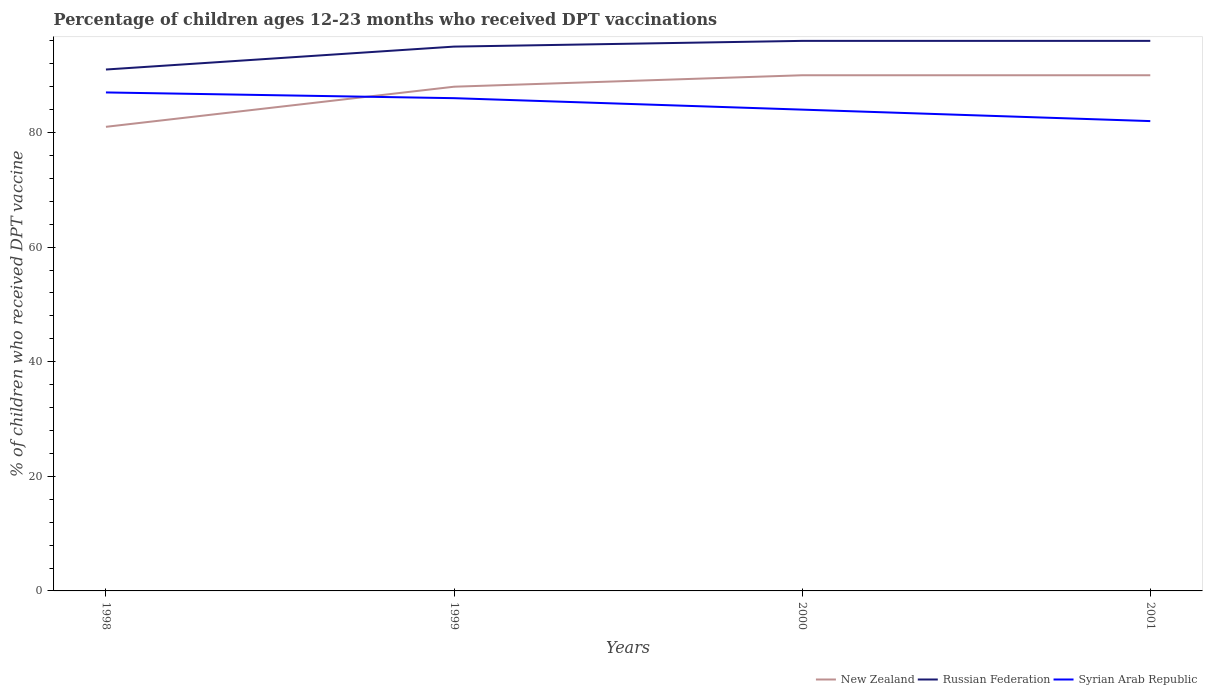Does the line corresponding to New Zealand intersect with the line corresponding to Russian Federation?
Your response must be concise. No. Is the number of lines equal to the number of legend labels?
Provide a short and direct response. Yes. Across all years, what is the maximum percentage of children who received DPT vaccination in New Zealand?
Offer a very short reply. 81. What is the total percentage of children who received DPT vaccination in Syrian Arab Republic in the graph?
Give a very brief answer. 2. What is the difference between the highest and the second highest percentage of children who received DPT vaccination in Russian Federation?
Your answer should be very brief. 5. What is the difference between the highest and the lowest percentage of children who received DPT vaccination in New Zealand?
Give a very brief answer. 3. Is the percentage of children who received DPT vaccination in Russian Federation strictly greater than the percentage of children who received DPT vaccination in New Zealand over the years?
Ensure brevity in your answer.  No. What is the difference between two consecutive major ticks on the Y-axis?
Offer a very short reply. 20. Are the values on the major ticks of Y-axis written in scientific E-notation?
Ensure brevity in your answer.  No. Does the graph contain grids?
Your answer should be compact. No. How many legend labels are there?
Your answer should be very brief. 3. What is the title of the graph?
Provide a succinct answer. Percentage of children ages 12-23 months who received DPT vaccinations. Does "Greece" appear as one of the legend labels in the graph?
Your answer should be very brief. No. What is the label or title of the Y-axis?
Give a very brief answer. % of children who received DPT vaccine. What is the % of children who received DPT vaccine of Russian Federation in 1998?
Provide a short and direct response. 91. What is the % of children who received DPT vaccine in Syrian Arab Republic in 1998?
Make the answer very short. 87. What is the % of children who received DPT vaccine in New Zealand in 1999?
Your answer should be very brief. 88. What is the % of children who received DPT vaccine of Syrian Arab Republic in 1999?
Your response must be concise. 86. What is the % of children who received DPT vaccine of New Zealand in 2000?
Provide a succinct answer. 90. What is the % of children who received DPT vaccine in Russian Federation in 2000?
Your response must be concise. 96. What is the % of children who received DPT vaccine of Syrian Arab Republic in 2000?
Provide a short and direct response. 84. What is the % of children who received DPT vaccine of New Zealand in 2001?
Keep it short and to the point. 90. What is the % of children who received DPT vaccine in Russian Federation in 2001?
Offer a very short reply. 96. Across all years, what is the maximum % of children who received DPT vaccine in Russian Federation?
Offer a very short reply. 96. Across all years, what is the minimum % of children who received DPT vaccine in Russian Federation?
Your response must be concise. 91. What is the total % of children who received DPT vaccine in New Zealand in the graph?
Make the answer very short. 349. What is the total % of children who received DPT vaccine of Russian Federation in the graph?
Provide a succinct answer. 378. What is the total % of children who received DPT vaccine in Syrian Arab Republic in the graph?
Provide a short and direct response. 339. What is the difference between the % of children who received DPT vaccine in New Zealand in 1998 and that in 1999?
Offer a terse response. -7. What is the difference between the % of children who received DPT vaccine of Russian Federation in 1998 and that in 2001?
Your answer should be very brief. -5. What is the difference between the % of children who received DPT vaccine of Syrian Arab Republic in 1998 and that in 2001?
Provide a succinct answer. 5. What is the difference between the % of children who received DPT vaccine of Russian Federation in 1999 and that in 2000?
Give a very brief answer. -1. What is the difference between the % of children who received DPT vaccine of New Zealand in 1999 and that in 2001?
Provide a short and direct response. -2. What is the difference between the % of children who received DPT vaccine in Russian Federation in 1999 and that in 2001?
Offer a very short reply. -1. What is the difference between the % of children who received DPT vaccine in Syrian Arab Republic in 1999 and that in 2001?
Your answer should be very brief. 4. What is the difference between the % of children who received DPT vaccine of Russian Federation in 2000 and that in 2001?
Your answer should be very brief. 0. What is the difference between the % of children who received DPT vaccine of New Zealand in 1998 and the % of children who received DPT vaccine of Syrian Arab Republic in 1999?
Give a very brief answer. -5. What is the difference between the % of children who received DPT vaccine in Russian Federation in 1998 and the % of children who received DPT vaccine in Syrian Arab Republic in 1999?
Provide a short and direct response. 5. What is the difference between the % of children who received DPT vaccine of New Zealand in 1998 and the % of children who received DPT vaccine of Russian Federation in 2001?
Offer a very short reply. -15. What is the difference between the % of children who received DPT vaccine of New Zealand in 1998 and the % of children who received DPT vaccine of Syrian Arab Republic in 2001?
Provide a succinct answer. -1. What is the difference between the % of children who received DPT vaccine in New Zealand in 1999 and the % of children who received DPT vaccine in Russian Federation in 2000?
Give a very brief answer. -8. What is the difference between the % of children who received DPT vaccine of New Zealand in 1999 and the % of children who received DPT vaccine of Syrian Arab Republic in 2000?
Offer a terse response. 4. What is the difference between the % of children who received DPT vaccine of Russian Federation in 1999 and the % of children who received DPT vaccine of Syrian Arab Republic in 2000?
Give a very brief answer. 11. What is the difference between the % of children who received DPT vaccine of New Zealand in 1999 and the % of children who received DPT vaccine of Russian Federation in 2001?
Make the answer very short. -8. What is the difference between the % of children who received DPT vaccine of Russian Federation in 1999 and the % of children who received DPT vaccine of Syrian Arab Republic in 2001?
Your answer should be very brief. 13. What is the difference between the % of children who received DPT vaccine in Russian Federation in 2000 and the % of children who received DPT vaccine in Syrian Arab Republic in 2001?
Ensure brevity in your answer.  14. What is the average % of children who received DPT vaccine of New Zealand per year?
Your answer should be very brief. 87.25. What is the average % of children who received DPT vaccine in Russian Federation per year?
Keep it short and to the point. 94.5. What is the average % of children who received DPT vaccine in Syrian Arab Republic per year?
Your response must be concise. 84.75. In the year 1998, what is the difference between the % of children who received DPT vaccine in New Zealand and % of children who received DPT vaccine in Syrian Arab Republic?
Offer a very short reply. -6. In the year 1998, what is the difference between the % of children who received DPT vaccine in Russian Federation and % of children who received DPT vaccine in Syrian Arab Republic?
Your answer should be compact. 4. In the year 1999, what is the difference between the % of children who received DPT vaccine of New Zealand and % of children who received DPT vaccine of Russian Federation?
Ensure brevity in your answer.  -7. In the year 1999, what is the difference between the % of children who received DPT vaccine of New Zealand and % of children who received DPT vaccine of Syrian Arab Republic?
Offer a terse response. 2. In the year 1999, what is the difference between the % of children who received DPT vaccine in Russian Federation and % of children who received DPT vaccine in Syrian Arab Republic?
Make the answer very short. 9. In the year 2000, what is the difference between the % of children who received DPT vaccine of New Zealand and % of children who received DPT vaccine of Russian Federation?
Make the answer very short. -6. In the year 2001, what is the difference between the % of children who received DPT vaccine of New Zealand and % of children who received DPT vaccine of Russian Federation?
Make the answer very short. -6. What is the ratio of the % of children who received DPT vaccine in New Zealand in 1998 to that in 1999?
Make the answer very short. 0.92. What is the ratio of the % of children who received DPT vaccine in Russian Federation in 1998 to that in 1999?
Your response must be concise. 0.96. What is the ratio of the % of children who received DPT vaccine of Syrian Arab Republic in 1998 to that in 1999?
Provide a succinct answer. 1.01. What is the ratio of the % of children who received DPT vaccine in New Zealand in 1998 to that in 2000?
Provide a succinct answer. 0.9. What is the ratio of the % of children who received DPT vaccine in Russian Federation in 1998 to that in 2000?
Your answer should be very brief. 0.95. What is the ratio of the % of children who received DPT vaccine in Syrian Arab Republic in 1998 to that in 2000?
Provide a short and direct response. 1.04. What is the ratio of the % of children who received DPT vaccine of New Zealand in 1998 to that in 2001?
Offer a very short reply. 0.9. What is the ratio of the % of children who received DPT vaccine of Russian Federation in 1998 to that in 2001?
Offer a very short reply. 0.95. What is the ratio of the % of children who received DPT vaccine of Syrian Arab Republic in 1998 to that in 2001?
Give a very brief answer. 1.06. What is the ratio of the % of children who received DPT vaccine in New Zealand in 1999 to that in 2000?
Provide a succinct answer. 0.98. What is the ratio of the % of children who received DPT vaccine in Russian Federation in 1999 to that in 2000?
Your answer should be very brief. 0.99. What is the ratio of the % of children who received DPT vaccine of Syrian Arab Republic in 1999 to that in 2000?
Your answer should be compact. 1.02. What is the ratio of the % of children who received DPT vaccine in New Zealand in 1999 to that in 2001?
Offer a very short reply. 0.98. What is the ratio of the % of children who received DPT vaccine of Russian Federation in 1999 to that in 2001?
Keep it short and to the point. 0.99. What is the ratio of the % of children who received DPT vaccine in Syrian Arab Republic in 1999 to that in 2001?
Offer a very short reply. 1.05. What is the ratio of the % of children who received DPT vaccine in New Zealand in 2000 to that in 2001?
Your answer should be compact. 1. What is the ratio of the % of children who received DPT vaccine in Syrian Arab Republic in 2000 to that in 2001?
Give a very brief answer. 1.02. What is the difference between the highest and the second highest % of children who received DPT vaccine of New Zealand?
Your answer should be compact. 0. What is the difference between the highest and the second highest % of children who received DPT vaccine in Russian Federation?
Your response must be concise. 0. What is the difference between the highest and the lowest % of children who received DPT vaccine of Russian Federation?
Ensure brevity in your answer.  5. 